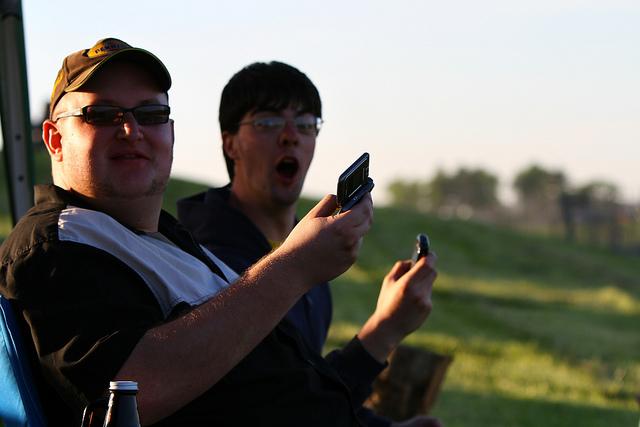Is there sunny?
Be succinct. Yes. Is it night or day?
Concise answer only. Day. Is the man angry?
Concise answer only. No. 